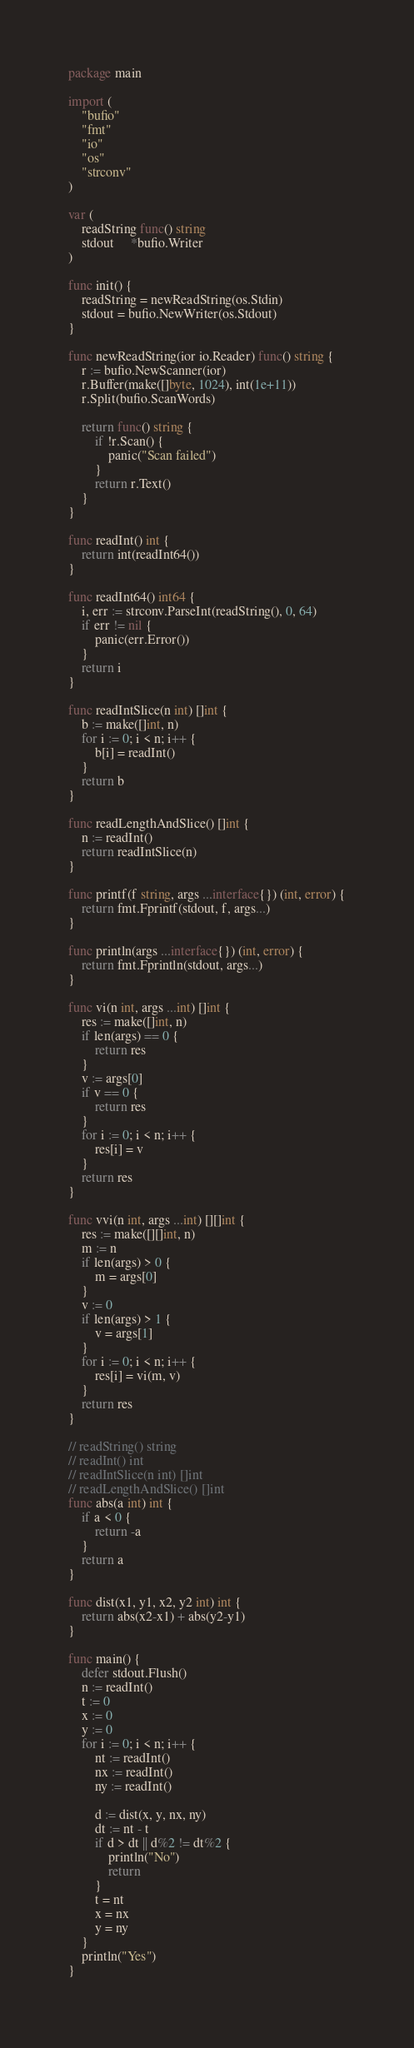<code> <loc_0><loc_0><loc_500><loc_500><_Go_>package main

import (
	"bufio"
	"fmt"
	"io"
	"os"
	"strconv"
)

var (
	readString func() string
	stdout     *bufio.Writer
)

func init() {
	readString = newReadString(os.Stdin)
	stdout = bufio.NewWriter(os.Stdout)
}

func newReadString(ior io.Reader) func() string {
	r := bufio.NewScanner(ior)
	r.Buffer(make([]byte, 1024), int(1e+11))
	r.Split(bufio.ScanWords)

	return func() string {
		if !r.Scan() {
			panic("Scan failed")
		}
		return r.Text()
	}
}

func readInt() int {
	return int(readInt64())
}

func readInt64() int64 {
	i, err := strconv.ParseInt(readString(), 0, 64)
	if err != nil {
		panic(err.Error())
	}
	return i
}

func readIntSlice(n int) []int {
	b := make([]int, n)
	for i := 0; i < n; i++ {
		b[i] = readInt()
	}
	return b
}

func readLengthAndSlice() []int {
	n := readInt()
	return readIntSlice(n)
}

func printf(f string, args ...interface{}) (int, error) {
	return fmt.Fprintf(stdout, f, args...)
}

func println(args ...interface{}) (int, error) {
	return fmt.Fprintln(stdout, args...)
}

func vi(n int, args ...int) []int {
	res := make([]int, n)
	if len(args) == 0 {
		return res
	}
	v := args[0]
	if v == 0 {
		return res
	}
	for i := 0; i < n; i++ {
		res[i] = v
	}
	return res
}

func vvi(n int, args ...int) [][]int {
	res := make([][]int, n)
	m := n
	if len(args) > 0 {
		m = args[0]
	}
	v := 0
	if len(args) > 1 {
		v = args[1]
	}
	for i := 0; i < n; i++ {
		res[i] = vi(m, v)
	}
	return res
}

// readString() string
// readInt() int
// readIntSlice(n int) []int
// readLengthAndSlice() []int
func abs(a int) int {
	if a < 0 {
		return -a
	}
	return a
}

func dist(x1, y1, x2, y2 int) int {
	return abs(x2-x1) + abs(y2-y1)
}

func main() {
	defer stdout.Flush()
	n := readInt()
	t := 0
	x := 0
	y := 0
	for i := 0; i < n; i++ {
		nt := readInt()
		nx := readInt()
		ny := readInt()

		d := dist(x, y, nx, ny)
		dt := nt - t
		if d > dt || d%2 != dt%2 {
			println("No")
			return
		}
		t = nt
		x = nx
		y = ny
	}
	println("Yes")
}
</code> 